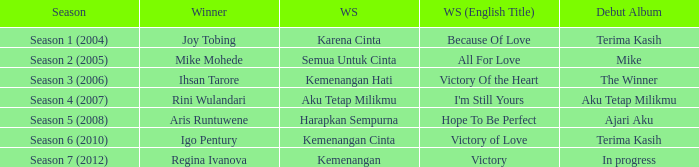Which winning song was sung by aku tetap milikmu? I'm Still Yours. 